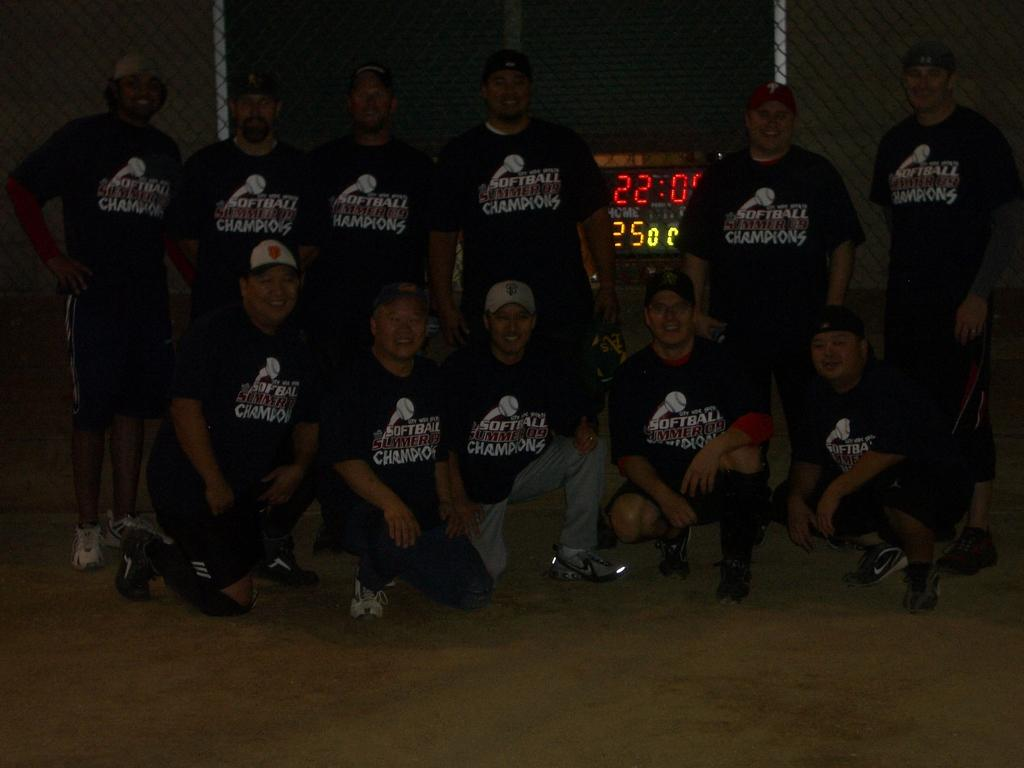<image>
Give a short and clear explanation of the subsequent image. A group of people wearing shirts saying "Softball champions!" pose for a photo. 